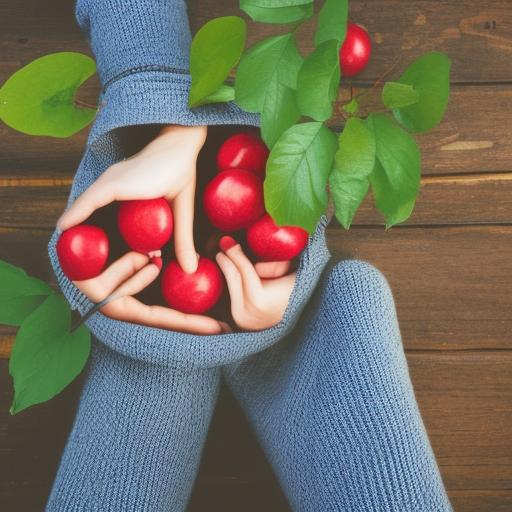How might this image be used in a commercial context? This image could effectively be used in advertising for health food stores, autumn-related promotions, or campaigns about sustainable living. The hands holding the apples symbolize care and freshness, which are compelling visuals for brands promoting organic produce or a healthy lifestyle. 